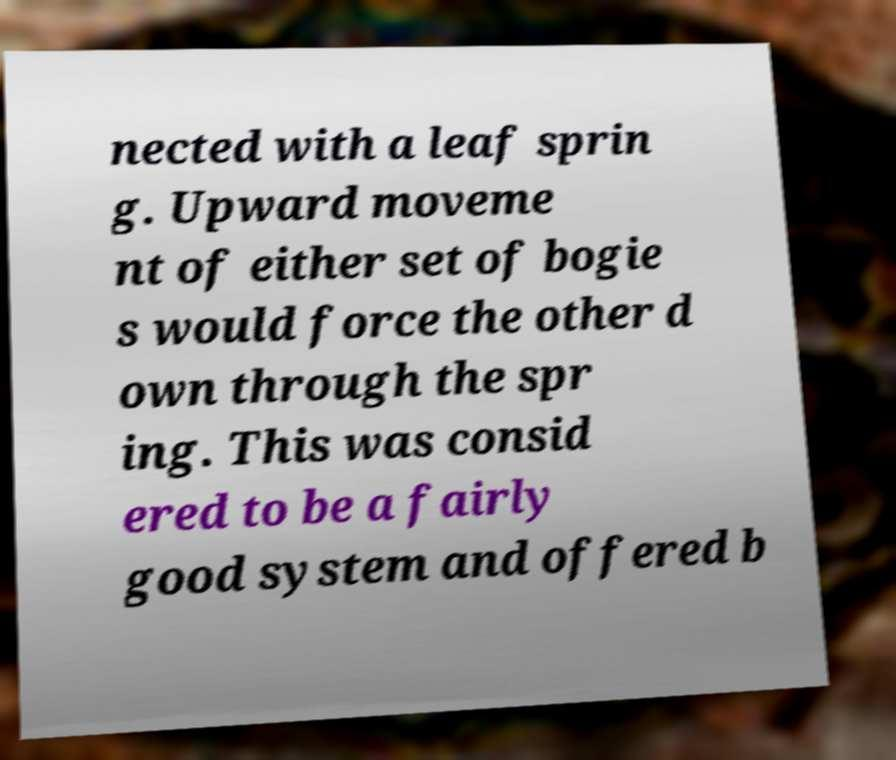There's text embedded in this image that I need extracted. Can you transcribe it verbatim? nected with a leaf sprin g. Upward moveme nt of either set of bogie s would force the other d own through the spr ing. This was consid ered to be a fairly good system and offered b 